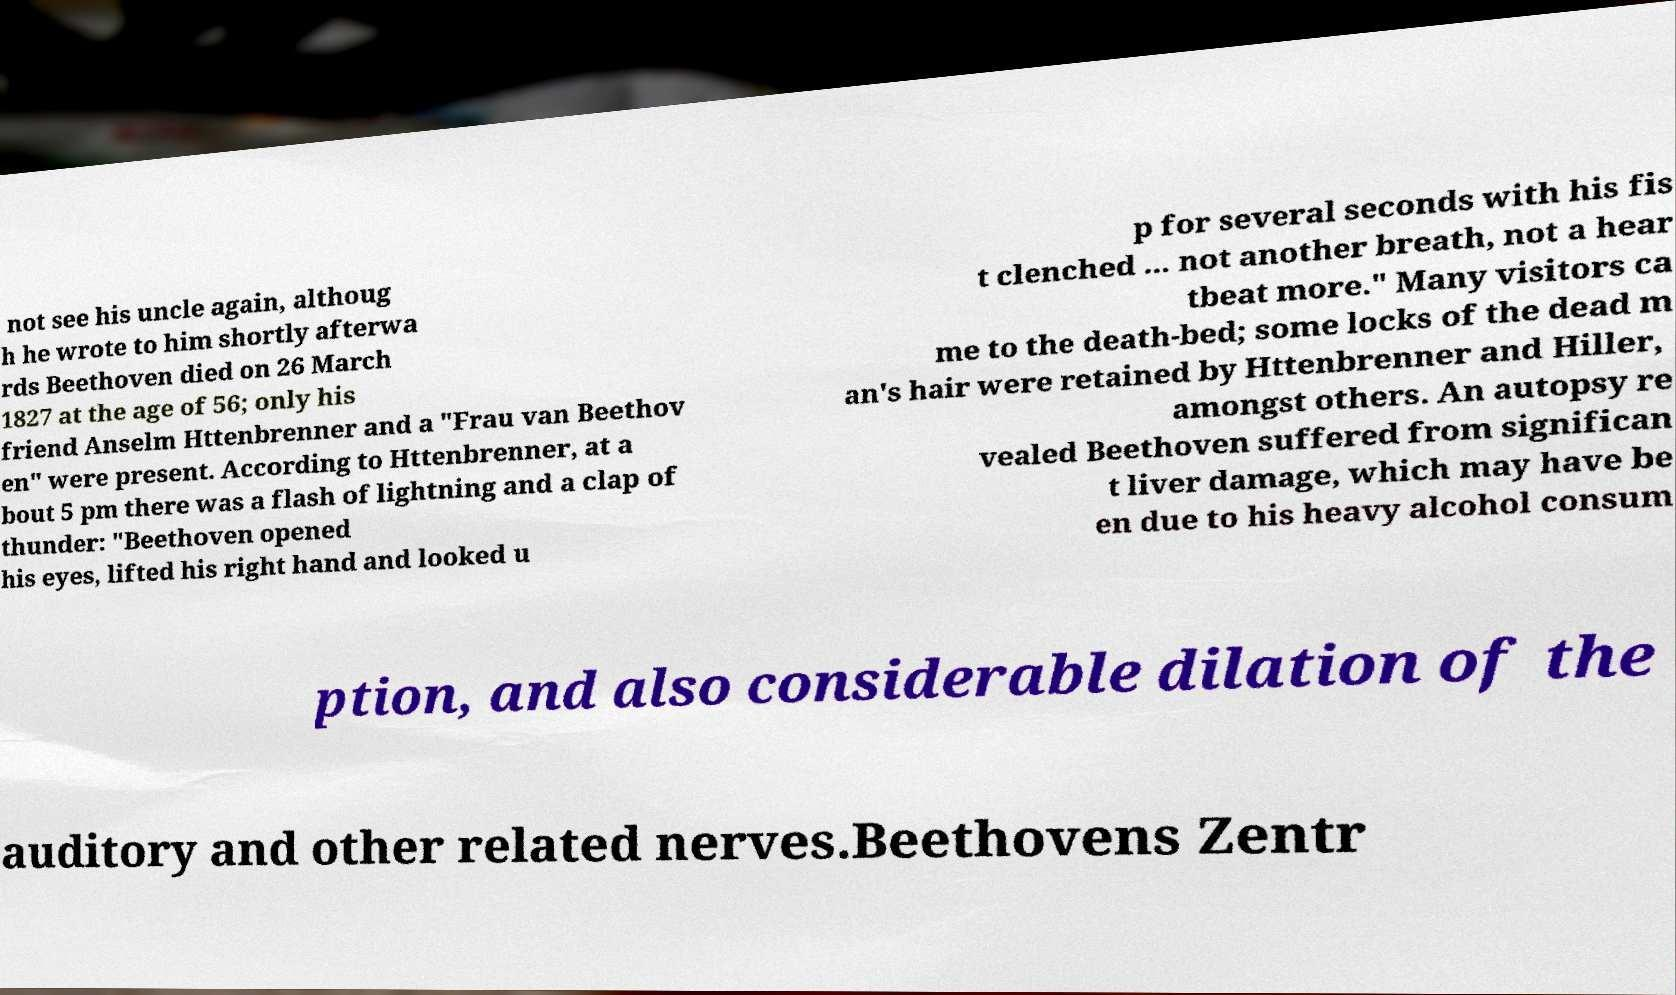Could you extract and type out the text from this image? not see his uncle again, althoug h he wrote to him shortly afterwa rds Beethoven died on 26 March 1827 at the age of 56; only his friend Anselm Httenbrenner and a "Frau van Beethov en" were present. According to Httenbrenner, at a bout 5 pm there was a flash of lightning and a clap of thunder: "Beethoven opened his eyes, lifted his right hand and looked u p for several seconds with his fis t clenched ... not another breath, not a hear tbeat more." Many visitors ca me to the death-bed; some locks of the dead m an's hair were retained by Httenbrenner and Hiller, amongst others. An autopsy re vealed Beethoven suffered from significan t liver damage, which may have be en due to his heavy alcohol consum ption, and also considerable dilation of the auditory and other related nerves.Beethovens Zentr 